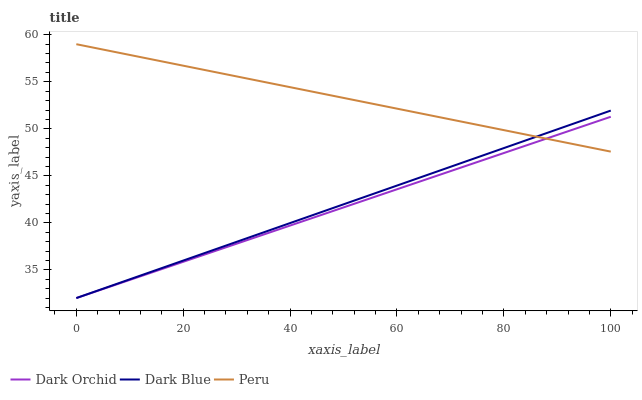Does Dark Orchid have the minimum area under the curve?
Answer yes or no. Yes. Does Peru have the maximum area under the curve?
Answer yes or no. Yes. Does Peru have the minimum area under the curve?
Answer yes or no. No. Does Dark Orchid have the maximum area under the curve?
Answer yes or no. No. Is Dark Orchid the smoothest?
Answer yes or no. Yes. Is Peru the roughest?
Answer yes or no. Yes. Is Peru the smoothest?
Answer yes or no. No. Is Dark Orchid the roughest?
Answer yes or no. No. Does Peru have the lowest value?
Answer yes or no. No. Does Peru have the highest value?
Answer yes or no. Yes. Does Dark Orchid have the highest value?
Answer yes or no. No. Does Dark Blue intersect Peru?
Answer yes or no. Yes. Is Dark Blue less than Peru?
Answer yes or no. No. Is Dark Blue greater than Peru?
Answer yes or no. No. 